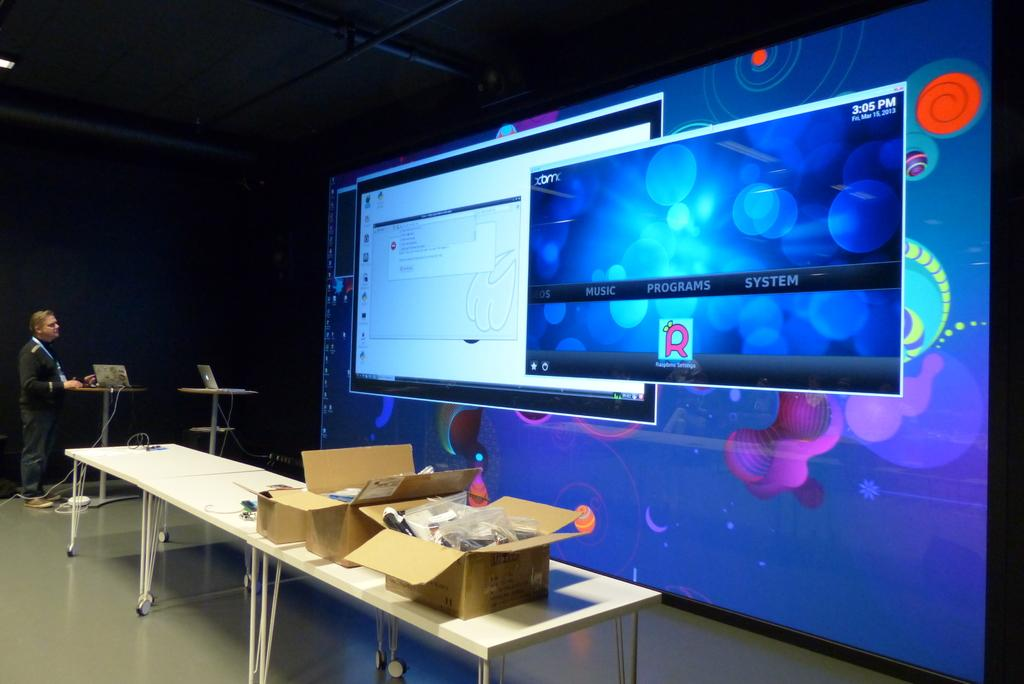Provide a one-sentence caption for the provided image. While one projected app has an error message, the other has loaded properly and displays, "EOS, Music, Programs, and System.". 